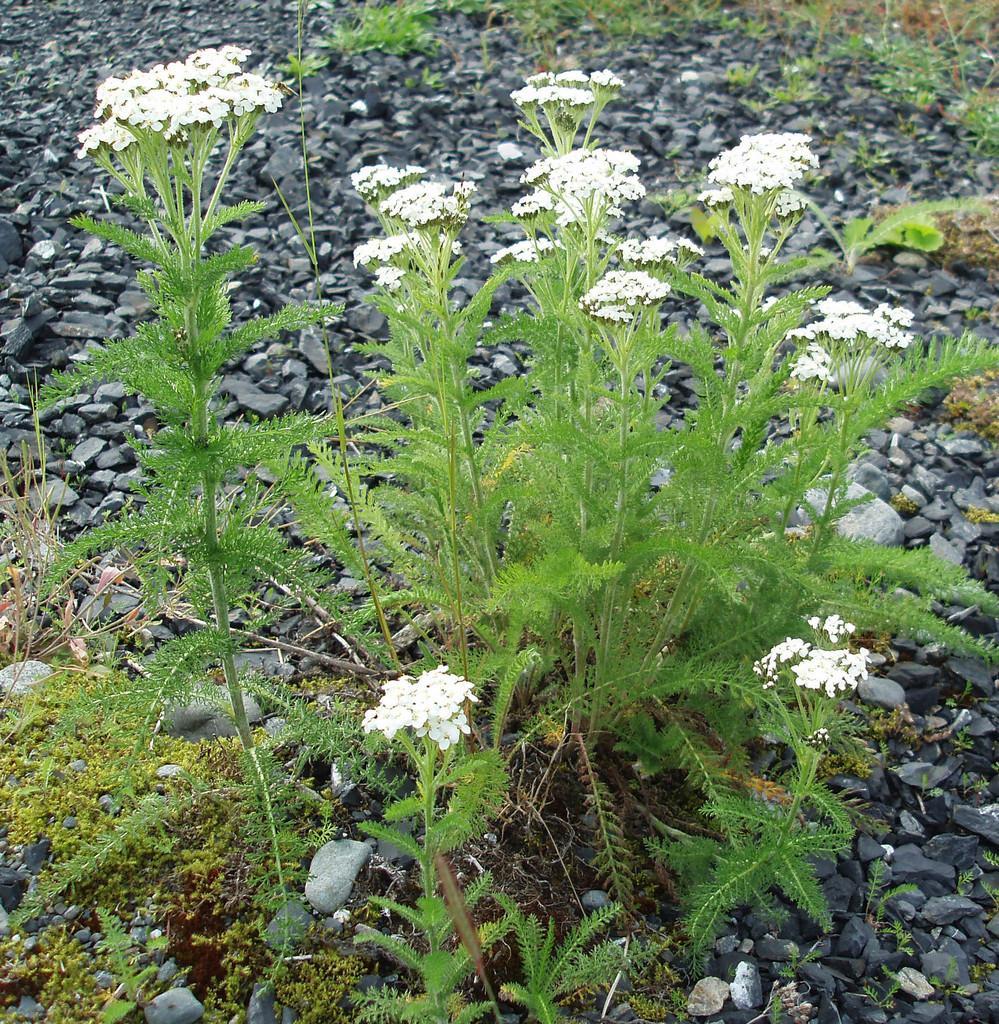Please provide a concise description of this image. In this image we can see plants, flowers, and stones. 